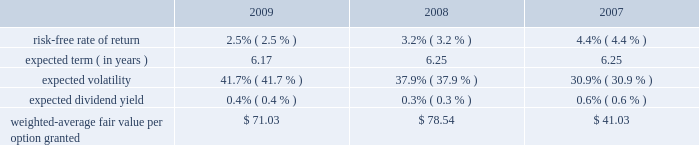Mastercard incorporated notes to consolidated financial statements 2014 ( continued ) ( in thousands , except percent and per share data ) upon termination of employment , excluding retirement , all of a participant 2019s unvested awards are forfeited .
However , when a participant terminates employment due to retirement , the participant generally retains all of their awards without providing additional service to the company .
Eligible retirement is dependent upon age and years of service , as follows : age 55 with ten years of service , age 60 with five years of service and age 65 with two years of service .
Compensation expense is recognized over the shorter of the vesting periods stated in the ltip , or the date the individual becomes eligible to retire .
There are 11550 shares of class a common stock reserved for equity awards under the ltip .
Although the ltip permits the issuance of shares of class b common stock , no such shares have been reserved for issuance .
Shares issued as a result of option exercises and the conversions of rsus are expected to be funded with the issuance of new shares of class a common stock .
Stock options the fair value of each option is estimated on the date of grant using a black-scholes option pricing model .
The table presents the weighted-average assumptions used in the valuation and the resulting weighted- average fair value per option granted for the years ended december 31: .
The risk-free rate of return was based on the u.s .
Treasury yield curve in effect on the date of grant .
The company utilizes the simplified method for calculating the expected term of the option based on the vesting terms and the contractual life of the option .
The expected volatility for options granted during 2009 was based on the average of the implied volatility of mastercard and a blend of the historical volatility of mastercard and the historical volatility of a group of companies that management believes is generally comparable to mastercard .
The expected volatility for options granted during 2008 was based on the average of the implied volatility of mastercard and the historical volatility of a group of companies that management believes is generally comparable to mastercard .
As the company did not have sufficient publicly traded stock data historically , the expected volatility for options granted during 2007 was primarily based on the average of the historical and implied volatility of a group of companies that management believed was generally comparable to mastercard .
The expected dividend yields were based on the company 2019s expected annual dividend rate on the date of grant. .
What is the variation observed in the risk-free rate of return during 2008 and 2009? 
Rationale: it is the difference between those values .
Computations: (3.2% - 2.5%)
Answer: 0.007. 